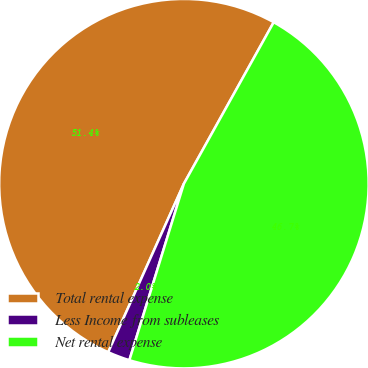Convert chart. <chart><loc_0><loc_0><loc_500><loc_500><pie_chart><fcel>Total rental expense<fcel>Less Income from subleases<fcel>Net rental expense<nl><fcel>51.36%<fcel>1.95%<fcel>46.69%<nl></chart> 